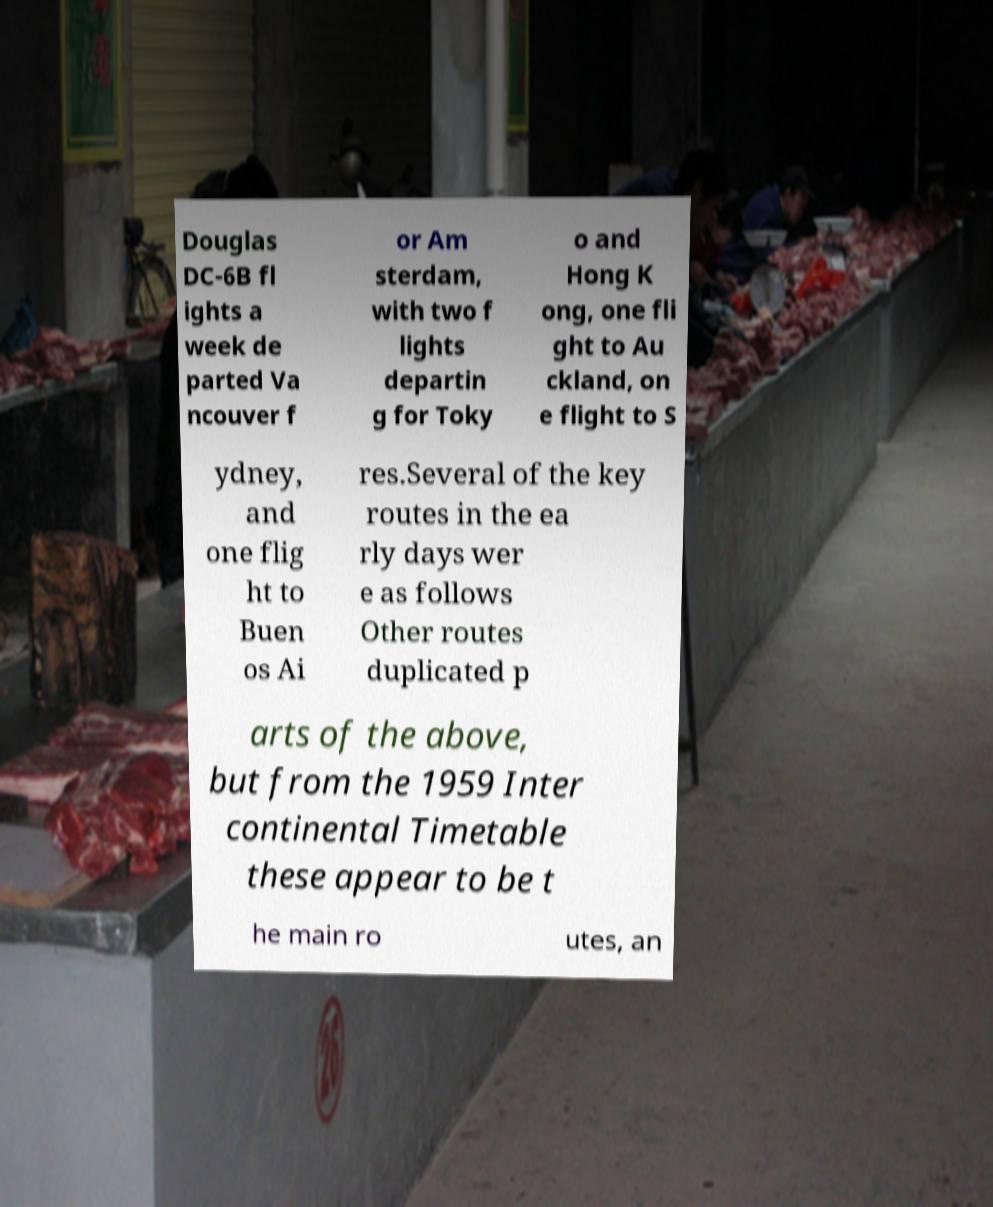There's text embedded in this image that I need extracted. Can you transcribe it verbatim? Douglas DC-6B fl ights a week de parted Va ncouver f or Am sterdam, with two f lights departin g for Toky o and Hong K ong, one fli ght to Au ckland, on e flight to S ydney, and one flig ht to Buen os Ai res.Several of the key routes in the ea rly days wer e as follows Other routes duplicated p arts of the above, but from the 1959 Inter continental Timetable these appear to be t he main ro utes, an 